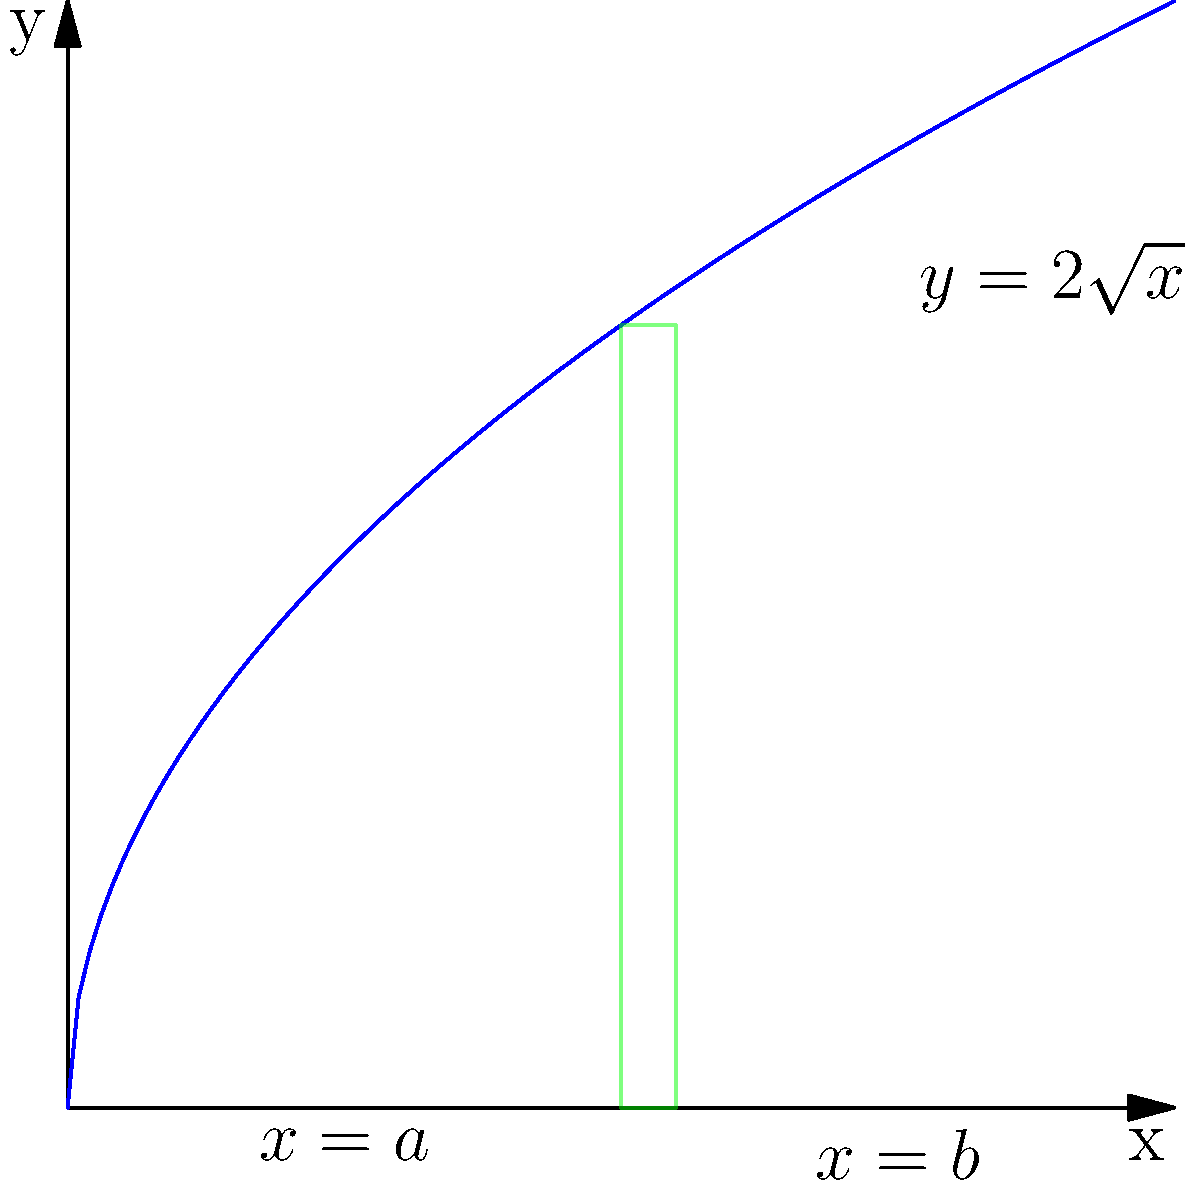Your child is designing a cylindrical component for an AR headset. The cross-section of the component follows the curve $y = 2\sqrt{x}$ from $x = 1$ to $x = 3$. If this curve is rotated around the y-axis to form the component, what is the volume of the resulting solid? (Hint: Use the method of cylindrical shells) Let's approach this step-by-step:

1) The method of cylindrical shells uses the formula:
   $V = 2\pi \int_a^b xf(x)dx$

   Where $x$ is the radius of each shell, and $f(x)$ is the height of each shell.

2) In this case:
   $f(x) = 2\sqrt{x}$
   $a = 1$ and $b = 3$

3) Substituting into our formula:
   $V = 2\pi \int_1^3 x(2\sqrt{x})dx$

4) Simplify:
   $V = 4\pi \int_1^3 x\sqrt{x}dx$

5) Substitute $u = x^{\frac{3}{2}}$, then $du = \frac{3}{2}x^{\frac{1}{2}}dx$ or $dx = \frac{2}{3}x^{-\frac{1}{2}}du$

6) Rewrite the integral:
   $V = 4\pi \int_1^3 \frac{2}{3}udu = \frac{8\pi}{3} \int_1^3 udu$

7) Integrate:
   $V = \frac{8\pi}{3} [\frac{1}{2}u^2]_1^3$

8) Evaluate the limits:
   $V = \frac{8\pi}{3} (\frac{1}{2}(3^3) - \frac{1}{2}(1^3))$
   $V = \frac{8\pi}{3} (\frac{27}{2} - \frac{1}{2})$
   $V = \frac{8\pi}{3} (13)$

9) Simplify:
   $V = \frac{104\pi}{3}$ cubic units
Answer: $\frac{104\pi}{3}$ cubic units 